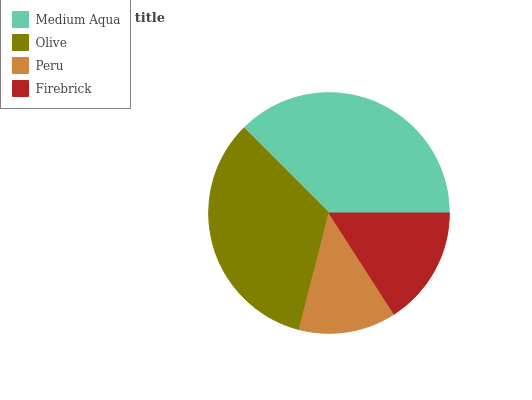Is Peru the minimum?
Answer yes or no. Yes. Is Medium Aqua the maximum?
Answer yes or no. Yes. Is Olive the minimum?
Answer yes or no. No. Is Olive the maximum?
Answer yes or no. No. Is Medium Aqua greater than Olive?
Answer yes or no. Yes. Is Olive less than Medium Aqua?
Answer yes or no. Yes. Is Olive greater than Medium Aqua?
Answer yes or no. No. Is Medium Aqua less than Olive?
Answer yes or no. No. Is Olive the high median?
Answer yes or no. Yes. Is Firebrick the low median?
Answer yes or no. Yes. Is Firebrick the high median?
Answer yes or no. No. Is Medium Aqua the low median?
Answer yes or no. No. 